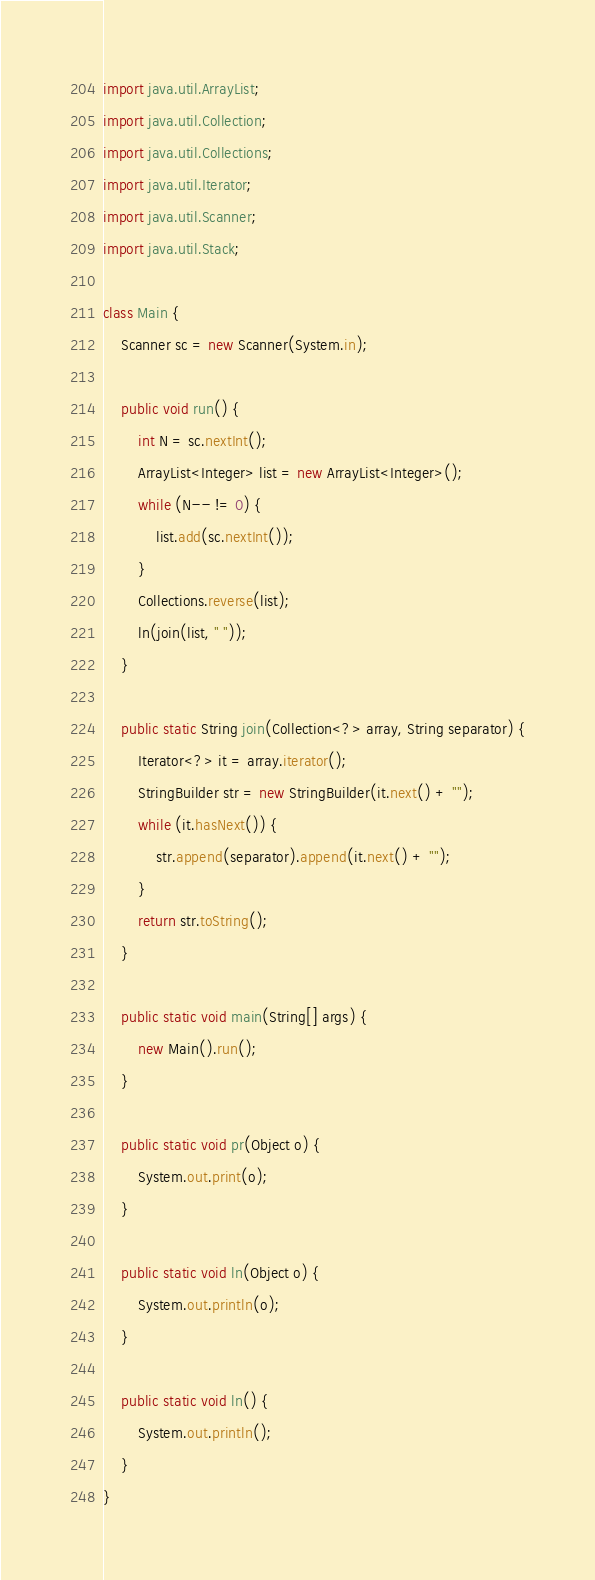Convert code to text. <code><loc_0><loc_0><loc_500><loc_500><_Java_>import java.util.ArrayList;
import java.util.Collection;
import java.util.Collections;
import java.util.Iterator;
import java.util.Scanner;
import java.util.Stack;
 
class Main {
    Scanner sc = new Scanner(System.in);
 
    public void run() {
        int N = sc.nextInt();
        ArrayList<Integer> list = new ArrayList<Integer>();
        while (N-- != 0) {
            list.add(sc.nextInt());
        }
        Collections.reverse(list);
        ln(join(list, " "));
    }
 
    public static String join(Collection<?> array, String separator) {
        Iterator<?> it = array.iterator();
        StringBuilder str = new StringBuilder(it.next() + "");
        while (it.hasNext()) {
            str.append(separator).append(it.next() + "");
        }
        return str.toString();
    }
 
    public static void main(String[] args) {
        new Main().run();
    }
 
    public static void pr(Object o) {
        System.out.print(o);
    }
 
    public static void ln(Object o) {
        System.out.println(o);
    }
 
    public static void ln() {
        System.out.println();
    }
}
</code> 